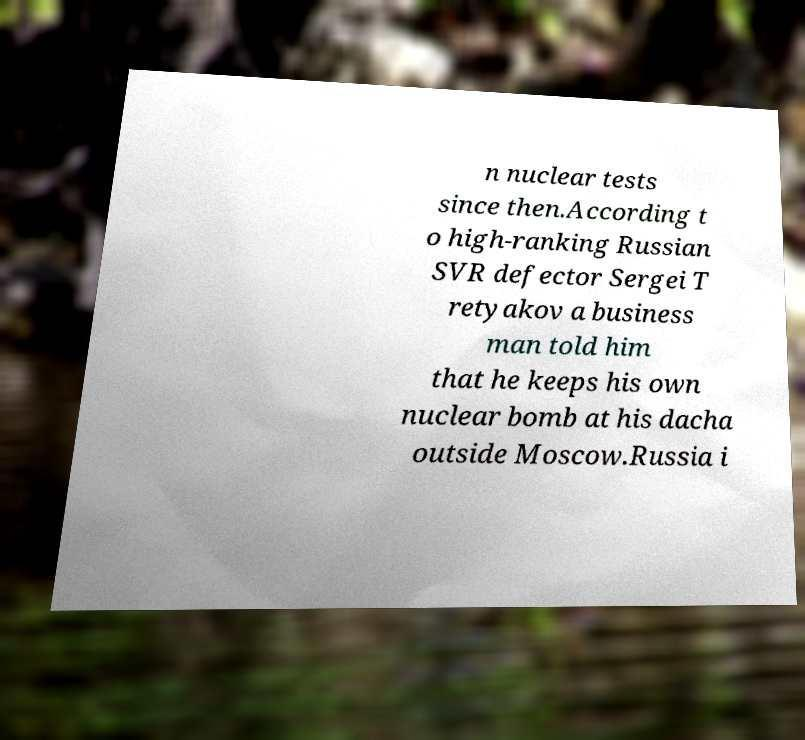For documentation purposes, I need the text within this image transcribed. Could you provide that? n nuclear tests since then.According t o high-ranking Russian SVR defector Sergei T retyakov a business man told him that he keeps his own nuclear bomb at his dacha outside Moscow.Russia i 